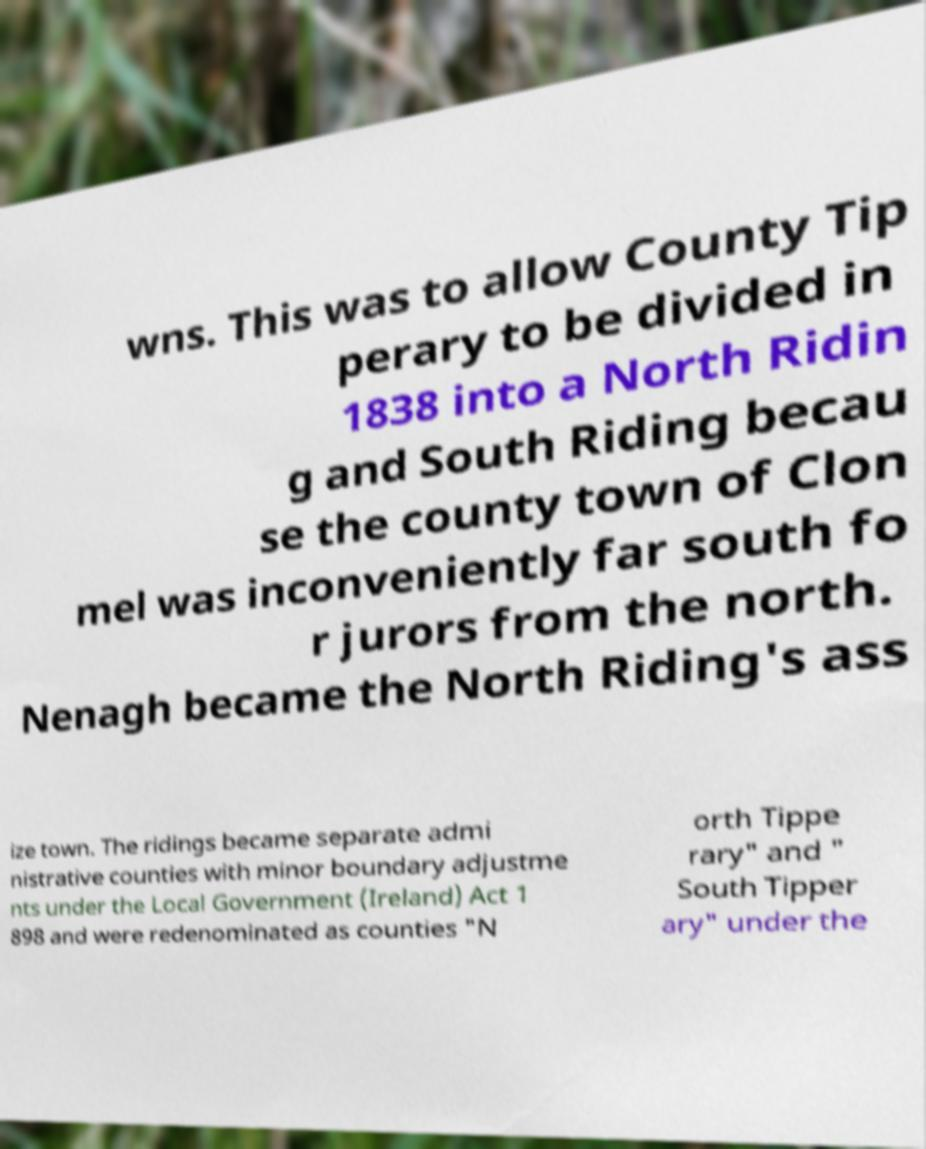Please identify and transcribe the text found in this image. wns. This was to allow County Tip perary to be divided in 1838 into a North Ridin g and South Riding becau se the county town of Clon mel was inconveniently far south fo r jurors from the north. Nenagh became the North Riding's ass ize town. The ridings became separate admi nistrative counties with minor boundary adjustme nts under the Local Government (Ireland) Act 1 898 and were redenominated as counties "N orth Tippe rary" and " South Tipper ary" under the 